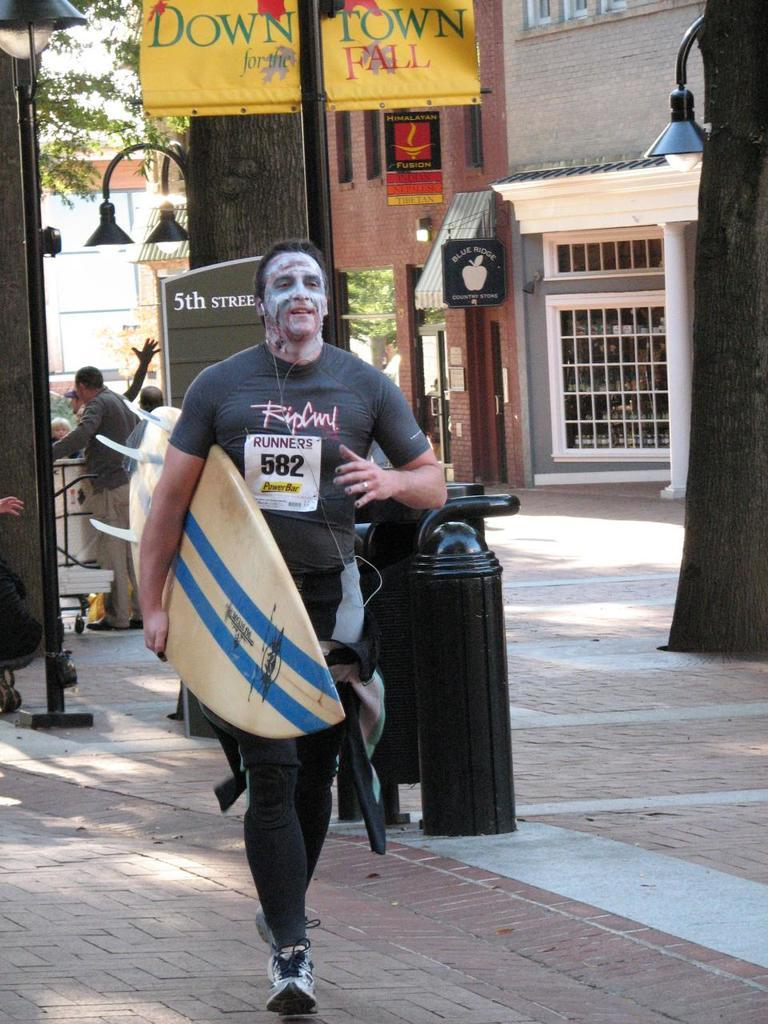Who is present in the image? There is a man in the image. What is the man doing in the image? The man is walking in the image. What is the man holding in the image? The man is holding a surfboard in the image. What can be seen in the background of the image? There is a building in the background of the image. Are there any other people visible in the image? Yes, there are people standing at the left side of the image. What type of fork can be seen in the man's hand in the image? There is no fork present in the image; the man is holding a surfboard. 